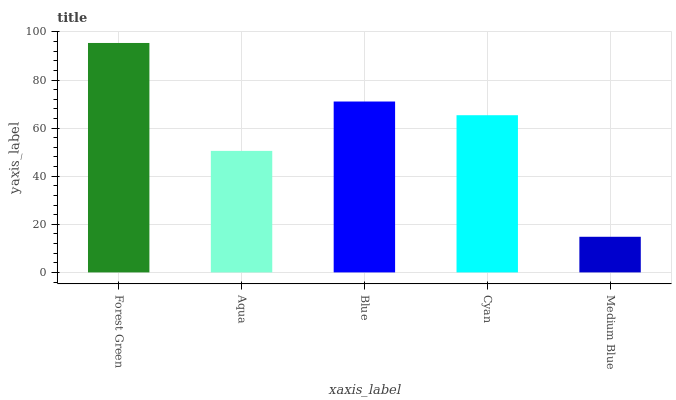Is Medium Blue the minimum?
Answer yes or no. Yes. Is Forest Green the maximum?
Answer yes or no. Yes. Is Aqua the minimum?
Answer yes or no. No. Is Aqua the maximum?
Answer yes or no. No. Is Forest Green greater than Aqua?
Answer yes or no. Yes. Is Aqua less than Forest Green?
Answer yes or no. Yes. Is Aqua greater than Forest Green?
Answer yes or no. No. Is Forest Green less than Aqua?
Answer yes or no. No. Is Cyan the high median?
Answer yes or no. Yes. Is Cyan the low median?
Answer yes or no. Yes. Is Blue the high median?
Answer yes or no. No. Is Forest Green the low median?
Answer yes or no. No. 